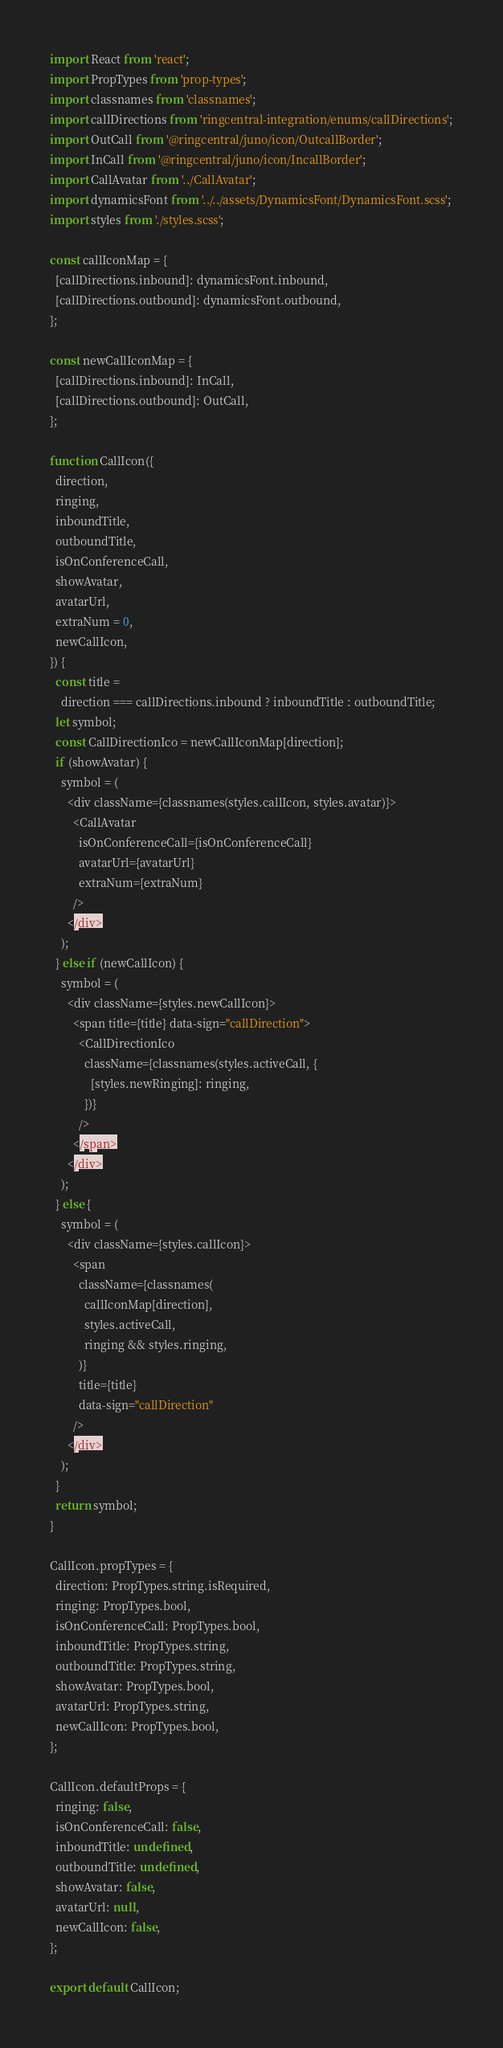<code> <loc_0><loc_0><loc_500><loc_500><_JavaScript_>import React from 'react';
import PropTypes from 'prop-types';
import classnames from 'classnames';
import callDirections from 'ringcentral-integration/enums/callDirections';
import OutCall from '@ringcentral/juno/icon/OutcallBorder';
import InCall from '@ringcentral/juno/icon/IncallBorder';
import CallAvatar from '../CallAvatar';
import dynamicsFont from '../../assets/DynamicsFont/DynamicsFont.scss';
import styles from './styles.scss';

const callIconMap = {
  [callDirections.inbound]: dynamicsFont.inbound,
  [callDirections.outbound]: dynamicsFont.outbound,
};

const newCallIconMap = {
  [callDirections.inbound]: InCall,
  [callDirections.outbound]: OutCall,
};

function CallIcon({
  direction,
  ringing,
  inboundTitle,
  outboundTitle,
  isOnConferenceCall,
  showAvatar,
  avatarUrl,
  extraNum = 0,
  newCallIcon,
}) {
  const title =
    direction === callDirections.inbound ? inboundTitle : outboundTitle;
  let symbol;
  const CallDirectionIco = newCallIconMap[direction];
  if (showAvatar) {
    symbol = (
      <div className={classnames(styles.callIcon, styles.avatar)}>
        <CallAvatar
          isOnConferenceCall={isOnConferenceCall}
          avatarUrl={avatarUrl}
          extraNum={extraNum}
        />
      </div>
    );
  } else if (newCallIcon) {
    symbol = (
      <div className={styles.newCallIcon}>
        <span title={title} data-sign="callDirection">
          <CallDirectionIco
            className={classnames(styles.activeCall, {
              [styles.newRinging]: ringing,
            })}
          />
        </span>
      </div>
    );
  } else {
    symbol = (
      <div className={styles.callIcon}>
        <span
          className={classnames(
            callIconMap[direction],
            styles.activeCall,
            ringing && styles.ringing,
          )}
          title={title}
          data-sign="callDirection"
        />
      </div>
    );
  }
  return symbol;
}

CallIcon.propTypes = {
  direction: PropTypes.string.isRequired,
  ringing: PropTypes.bool,
  isOnConferenceCall: PropTypes.bool,
  inboundTitle: PropTypes.string,
  outboundTitle: PropTypes.string,
  showAvatar: PropTypes.bool,
  avatarUrl: PropTypes.string,
  newCallIcon: PropTypes.bool,
};

CallIcon.defaultProps = {
  ringing: false,
  isOnConferenceCall: false,
  inboundTitle: undefined,
  outboundTitle: undefined,
  showAvatar: false,
  avatarUrl: null,
  newCallIcon: false,
};

export default CallIcon;
</code> 